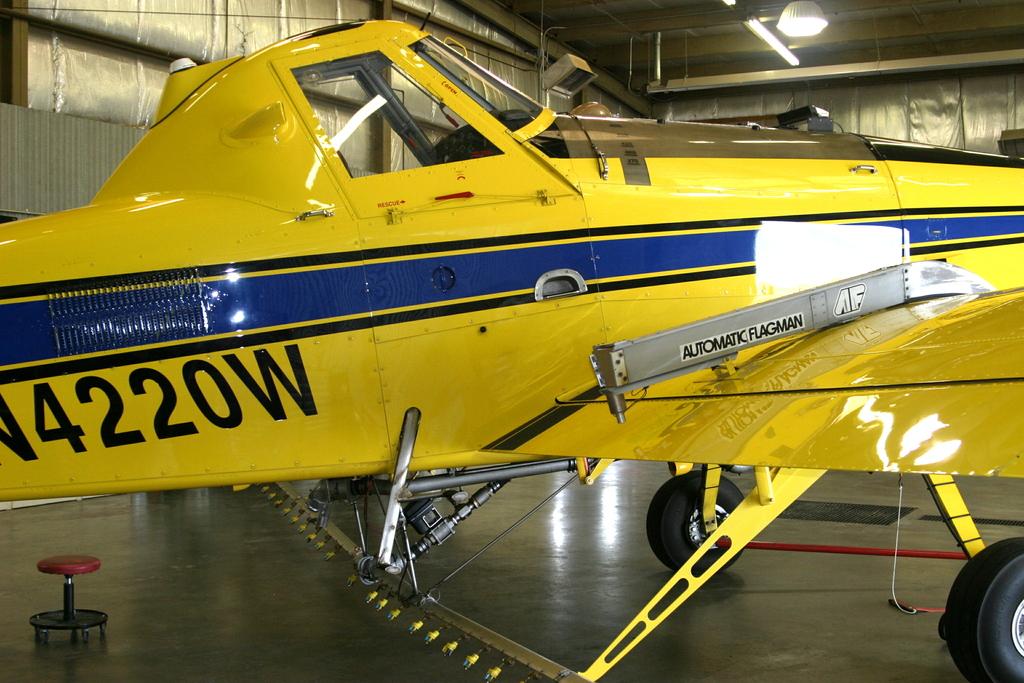What kind of flagman?
Your answer should be very brief. Automatic. What numbers are on the plane?
Provide a succinct answer. 4220. 